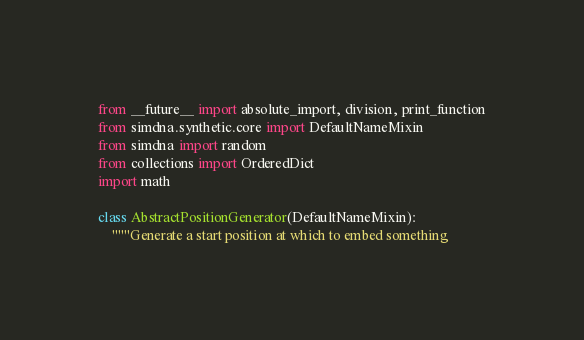Convert code to text. <code><loc_0><loc_0><loc_500><loc_500><_Python_>from __future__ import absolute_import, division, print_function
from simdna.synthetic.core import DefaultNameMixin
from simdna import random
from collections import OrderedDict
import math

class AbstractPositionGenerator(DefaultNameMixin):
    """Generate a start position at which to embed something
</code> 